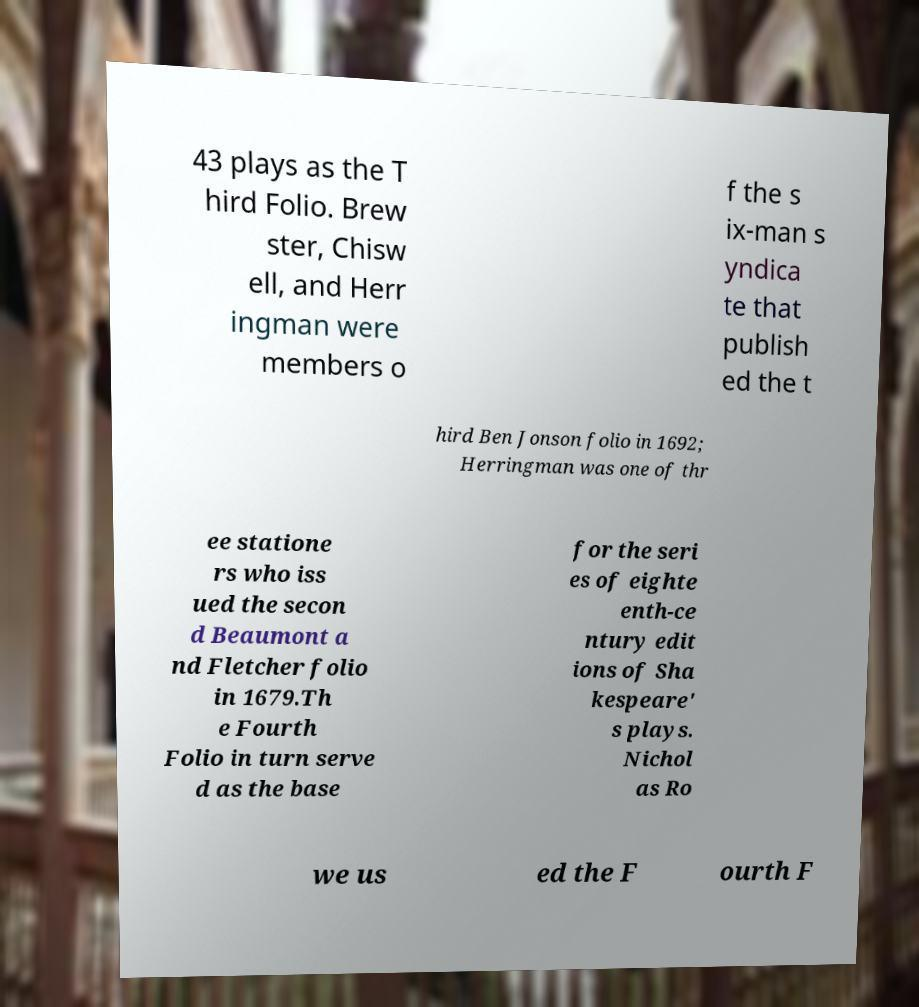For documentation purposes, I need the text within this image transcribed. Could you provide that? 43 plays as the T hird Folio. Brew ster, Chisw ell, and Herr ingman were members o f the s ix-man s yndica te that publish ed the t hird Ben Jonson folio in 1692; Herringman was one of thr ee statione rs who iss ued the secon d Beaumont a nd Fletcher folio in 1679.Th e Fourth Folio in turn serve d as the base for the seri es of eighte enth-ce ntury edit ions of Sha kespeare' s plays. Nichol as Ro we us ed the F ourth F 